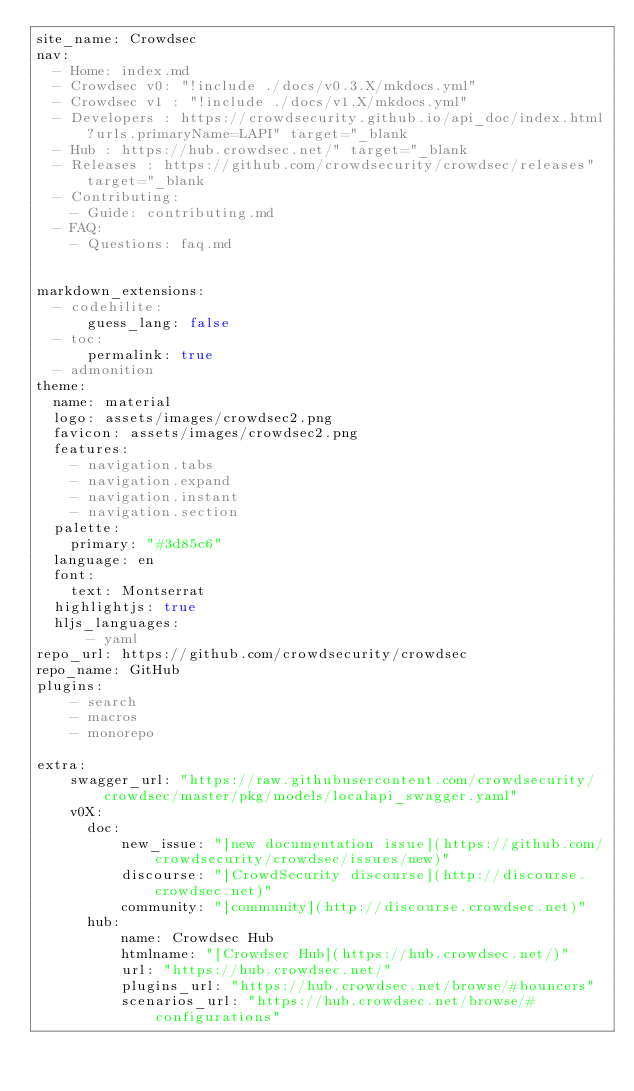Convert code to text. <code><loc_0><loc_0><loc_500><loc_500><_YAML_>site_name: Crowdsec
nav:
  - Home: index.md
  - Crowdsec v0: "!include ./docs/v0.3.X/mkdocs.yml"
  - Crowdsec v1 : "!include ./docs/v1.X/mkdocs.yml"
  - Developers : https://crowdsecurity.github.io/api_doc/index.html?urls.primaryName=LAPI" target="_blank
  - Hub : https://hub.crowdsec.net/" target="_blank
  - Releases : https://github.com/crowdsecurity/crowdsec/releases" target="_blank
  - Contributing:
    - Guide: contributing.md
  - FAQ:
    - Questions: faq.md


markdown_extensions:
  - codehilite:
      guess_lang: false
  - toc:
      permalink: true
  - admonition
theme: 
  name: material
  logo: assets/images/crowdsec2.png
  favicon: assets/images/crowdsec2.png
  features:
    - navigation.tabs
    - navigation.expand
    - navigation.instant
    - navigation.section
  palette:
    primary: "#3d85c6" 
  language: en
  font:
    text: Montserrat
  highlightjs: true
  hljs_languages:
      - yaml
repo_url: https://github.com/crowdsecurity/crowdsec
repo_name: GitHub
plugins:
    - search
    - macros
    - monorepo

extra:
    swagger_url: "https://raw.githubusercontent.com/crowdsecurity/crowdsec/master/pkg/models/localapi_swagger.yaml"
    v0X:
      doc:
          new_issue: "[new documentation issue](https://github.com/crowdsecurity/crowdsec/issues/new)"
          discourse: "[CrowdSecurity discourse](http://discourse.crowdsec.net)"
          community: "[community](http://discourse.crowdsec.net)"
      hub:
          name: Crowdsec Hub
          htmlname: "[Crowdsec Hub](https://hub.crowdsec.net/)"
          url: "https://hub.crowdsec.net/"
          plugins_url: "https://hub.crowdsec.net/browse/#bouncers"
          scenarios_url: "https://hub.crowdsec.net/browse/#configurations"</code> 